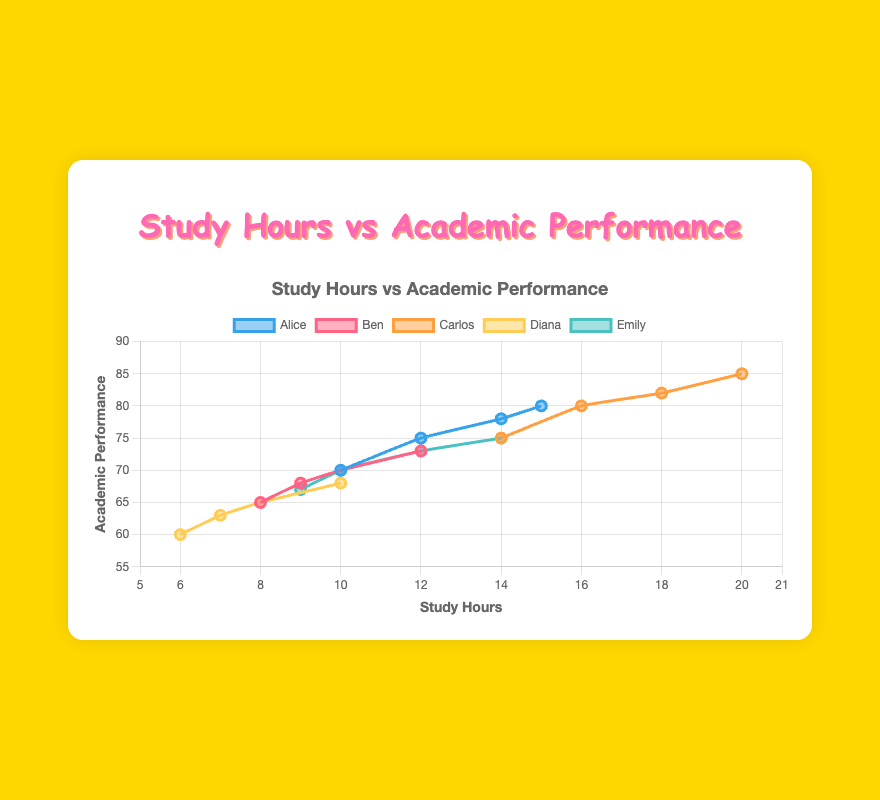How does Alice's academic performance change from Week 1 to Week 4? To see Alice's academic performance change, look at the grade values from Week 1 to Week 4: Week 1 (70), Week 2 (75), Week 3 (78), and Week 4 (80). The grades show a gradual improvement each week.
Answer: It steadily increases Which student has the highest number of study hours in Week 4? Check each student's study hours for Week 4: Alice (15), Ben (12), Carlos (20), Diana (10), Emily (14). Carlos has the highest number, with 20 study hours.
Answer: Carlos Who shows the most improvement in grades from Week 1 to Week 4? Calculate the grade difference for each student from Week 1 to Week 4: Alice (80-70=10), Ben (73-65=8), Carlos (85-75=10), Diana (68-60=8), Emily (75-67=8). Both Alice and Carlos have the highest improvement, with a difference of 10 points each.
Answer: Alice and Carlos What is the average academic performance of Emily across the 4 weeks? Sum Emily's grade values from Week 1 to Week 4, then divide by 4: (67 + 70 + 73 + 75)/4 = 285/4 = 71.25.
Answer: 71.25 Compare Carlos and Diana's study hours in Week 2. Who studied more, and by how much? Check their study hours in Week 2: Carlos (16), Diana (7). Carlos studied 16 - 7 = 9 hours more than Diana.
Answer: Carlos studied 9 more hours For which weeks did Alice achieve a higher grade than Ben? Compare Alice and Ben's grades week by week: Week 1 (Alice: 70, Ben: 65), Week 2 (Alice: 75, Ben: 68), Week 3 (Alice: 78, Ben: 70), Week 4 (Alice: 80, Ben: 73). Alice achieved higher grades in all weeks than Ben.
Answer: All weeks What’s the total study hours accumulated by Diana over the 4 weeks? Add up Diana's study hours: 6 (Week 1) + 7 (Week 2) + 8 (Week 3) + 10 (Week 4) = 31.
Answer: 31 Which student showed a linear increase in both study hours and grades? Check each student's hours and grades for linearity: Alice (10,70; 12,75; 14,78; 15,80), Ben (8,65; 9,68; 10,70; 12,73), Carlos (14,75; 16,80; 18,82; 20,85), Diana (6,60; 7,63; 8,65; 10,68), Emily (9,67; 10,70; 12,73; 14,75). Both Carlos and Alice have a more linear pattern in increases.
Answer: Carlos and Alice 